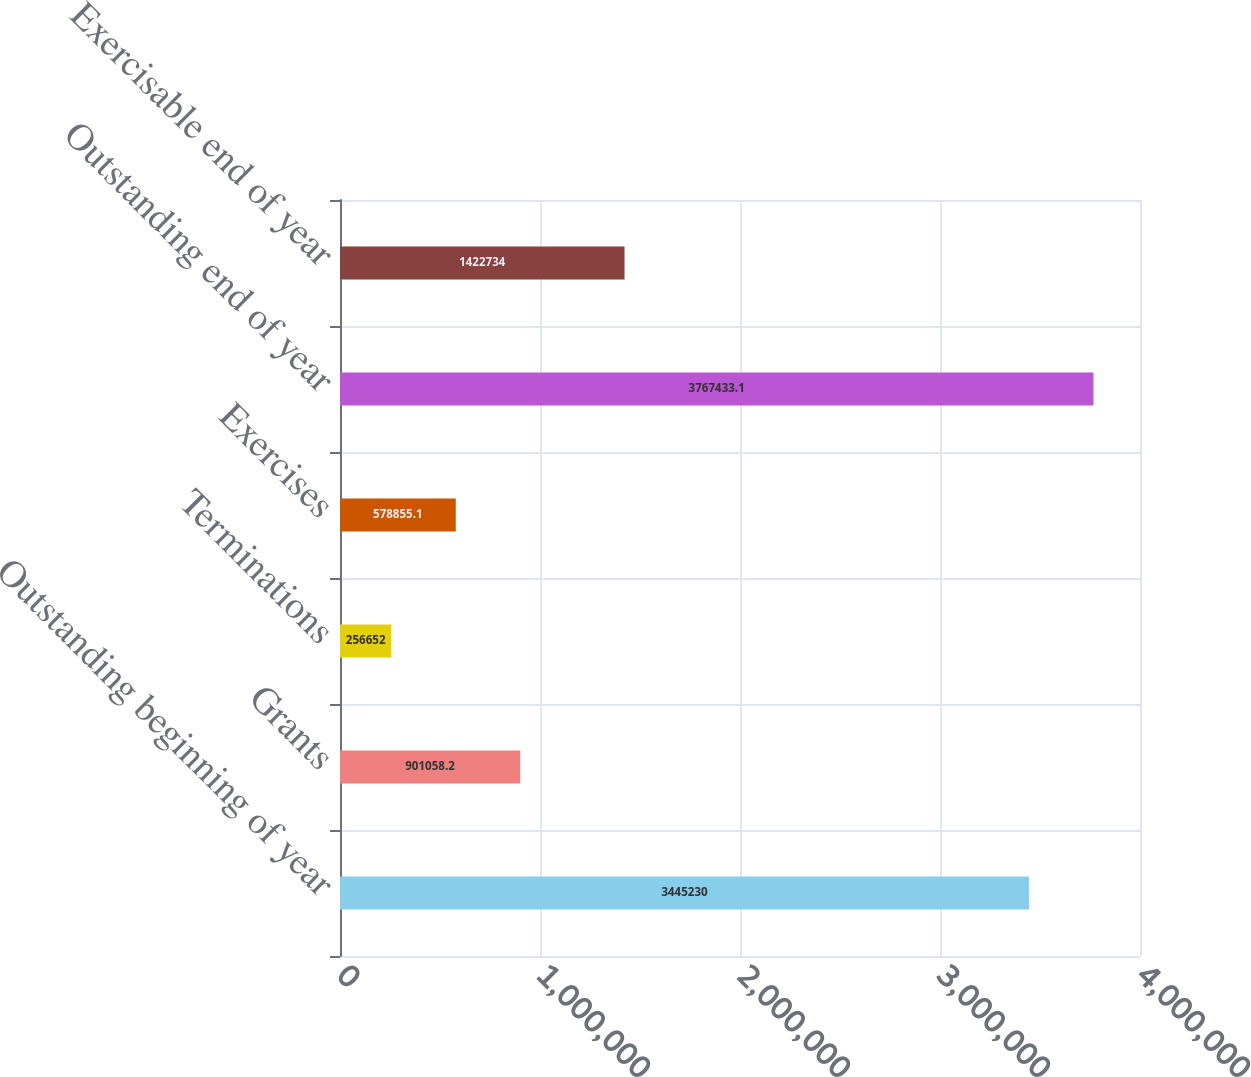Convert chart. <chart><loc_0><loc_0><loc_500><loc_500><bar_chart><fcel>Outstanding beginning of year<fcel>Grants<fcel>Terminations<fcel>Exercises<fcel>Outstanding end of year<fcel>Exercisable end of year<nl><fcel>3.44523e+06<fcel>901058<fcel>256652<fcel>578855<fcel>3.76743e+06<fcel>1.42273e+06<nl></chart> 